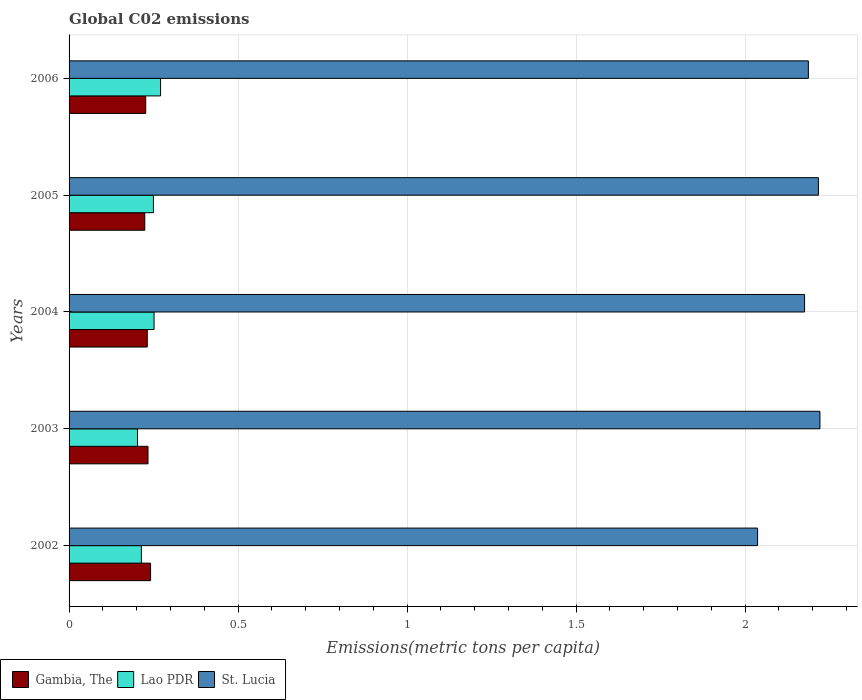How many different coloured bars are there?
Your answer should be compact. 3. Are the number of bars on each tick of the Y-axis equal?
Offer a terse response. Yes. How many bars are there on the 2nd tick from the top?
Keep it short and to the point. 3. What is the label of the 4th group of bars from the top?
Ensure brevity in your answer.  2003. What is the amount of CO2 emitted in in St. Lucia in 2002?
Provide a succinct answer. 2.04. Across all years, what is the maximum amount of CO2 emitted in in St. Lucia?
Provide a succinct answer. 2.22. Across all years, what is the minimum amount of CO2 emitted in in St. Lucia?
Offer a very short reply. 2.04. In which year was the amount of CO2 emitted in in Gambia, The minimum?
Make the answer very short. 2005. What is the total amount of CO2 emitted in in Gambia, The in the graph?
Provide a succinct answer. 1.16. What is the difference between the amount of CO2 emitted in in Gambia, The in 2005 and that in 2006?
Make the answer very short. -0. What is the difference between the amount of CO2 emitted in in Gambia, The in 2004 and the amount of CO2 emitted in in Lao PDR in 2003?
Provide a short and direct response. 0.03. What is the average amount of CO2 emitted in in St. Lucia per year?
Keep it short and to the point. 2.17. In the year 2006, what is the difference between the amount of CO2 emitted in in Gambia, The and amount of CO2 emitted in in Lao PDR?
Give a very brief answer. -0.04. In how many years, is the amount of CO2 emitted in in Gambia, The greater than 0.9 metric tons per capita?
Your answer should be very brief. 0. What is the ratio of the amount of CO2 emitted in in Gambia, The in 2005 to that in 2006?
Your answer should be compact. 0.99. What is the difference between the highest and the second highest amount of CO2 emitted in in Gambia, The?
Offer a very short reply. 0.01. What is the difference between the highest and the lowest amount of CO2 emitted in in Lao PDR?
Your response must be concise. 0.07. In how many years, is the amount of CO2 emitted in in St. Lucia greater than the average amount of CO2 emitted in in St. Lucia taken over all years?
Provide a short and direct response. 4. Is the sum of the amount of CO2 emitted in in Gambia, The in 2002 and 2005 greater than the maximum amount of CO2 emitted in in Lao PDR across all years?
Provide a succinct answer. Yes. What does the 1st bar from the top in 2003 represents?
Make the answer very short. St. Lucia. What does the 1st bar from the bottom in 2004 represents?
Ensure brevity in your answer.  Gambia, The. Are all the bars in the graph horizontal?
Ensure brevity in your answer.  Yes. How many legend labels are there?
Make the answer very short. 3. What is the title of the graph?
Give a very brief answer. Global C02 emissions. What is the label or title of the X-axis?
Offer a very short reply. Emissions(metric tons per capita). What is the Emissions(metric tons per capita) in Gambia, The in 2002?
Offer a terse response. 0.24. What is the Emissions(metric tons per capita) in Lao PDR in 2002?
Your answer should be compact. 0.21. What is the Emissions(metric tons per capita) in St. Lucia in 2002?
Provide a short and direct response. 2.04. What is the Emissions(metric tons per capita) in Gambia, The in 2003?
Offer a terse response. 0.23. What is the Emissions(metric tons per capita) in Lao PDR in 2003?
Your answer should be very brief. 0.2. What is the Emissions(metric tons per capita) in St. Lucia in 2003?
Your response must be concise. 2.22. What is the Emissions(metric tons per capita) in Gambia, The in 2004?
Provide a succinct answer. 0.23. What is the Emissions(metric tons per capita) of Lao PDR in 2004?
Ensure brevity in your answer.  0.25. What is the Emissions(metric tons per capita) of St. Lucia in 2004?
Your response must be concise. 2.18. What is the Emissions(metric tons per capita) of Gambia, The in 2005?
Keep it short and to the point. 0.22. What is the Emissions(metric tons per capita) of Lao PDR in 2005?
Your response must be concise. 0.25. What is the Emissions(metric tons per capita) of St. Lucia in 2005?
Keep it short and to the point. 2.22. What is the Emissions(metric tons per capita) of Gambia, The in 2006?
Give a very brief answer. 0.23. What is the Emissions(metric tons per capita) of Lao PDR in 2006?
Your response must be concise. 0.27. What is the Emissions(metric tons per capita) in St. Lucia in 2006?
Your response must be concise. 2.19. Across all years, what is the maximum Emissions(metric tons per capita) of Gambia, The?
Your response must be concise. 0.24. Across all years, what is the maximum Emissions(metric tons per capita) in Lao PDR?
Your answer should be very brief. 0.27. Across all years, what is the maximum Emissions(metric tons per capita) in St. Lucia?
Provide a short and direct response. 2.22. Across all years, what is the minimum Emissions(metric tons per capita) of Gambia, The?
Ensure brevity in your answer.  0.22. Across all years, what is the minimum Emissions(metric tons per capita) in Lao PDR?
Keep it short and to the point. 0.2. Across all years, what is the minimum Emissions(metric tons per capita) in St. Lucia?
Offer a very short reply. 2.04. What is the total Emissions(metric tons per capita) in Gambia, The in the graph?
Give a very brief answer. 1.16. What is the total Emissions(metric tons per capita) of Lao PDR in the graph?
Offer a very short reply. 1.19. What is the total Emissions(metric tons per capita) in St. Lucia in the graph?
Your answer should be very brief. 10.84. What is the difference between the Emissions(metric tons per capita) in Gambia, The in 2002 and that in 2003?
Give a very brief answer. 0.01. What is the difference between the Emissions(metric tons per capita) in Lao PDR in 2002 and that in 2003?
Offer a terse response. 0.01. What is the difference between the Emissions(metric tons per capita) of St. Lucia in 2002 and that in 2003?
Offer a terse response. -0.18. What is the difference between the Emissions(metric tons per capita) in Gambia, The in 2002 and that in 2004?
Provide a succinct answer. 0.01. What is the difference between the Emissions(metric tons per capita) of Lao PDR in 2002 and that in 2004?
Make the answer very short. -0.04. What is the difference between the Emissions(metric tons per capita) of St. Lucia in 2002 and that in 2004?
Ensure brevity in your answer.  -0.14. What is the difference between the Emissions(metric tons per capita) in Gambia, The in 2002 and that in 2005?
Your answer should be compact. 0.02. What is the difference between the Emissions(metric tons per capita) of Lao PDR in 2002 and that in 2005?
Your answer should be very brief. -0.04. What is the difference between the Emissions(metric tons per capita) of St. Lucia in 2002 and that in 2005?
Ensure brevity in your answer.  -0.18. What is the difference between the Emissions(metric tons per capita) in Gambia, The in 2002 and that in 2006?
Provide a succinct answer. 0.01. What is the difference between the Emissions(metric tons per capita) of Lao PDR in 2002 and that in 2006?
Your answer should be compact. -0.06. What is the difference between the Emissions(metric tons per capita) of St. Lucia in 2002 and that in 2006?
Ensure brevity in your answer.  -0.15. What is the difference between the Emissions(metric tons per capita) of Gambia, The in 2003 and that in 2004?
Provide a succinct answer. 0. What is the difference between the Emissions(metric tons per capita) in Lao PDR in 2003 and that in 2004?
Provide a short and direct response. -0.05. What is the difference between the Emissions(metric tons per capita) in St. Lucia in 2003 and that in 2004?
Provide a succinct answer. 0.05. What is the difference between the Emissions(metric tons per capita) in Gambia, The in 2003 and that in 2005?
Your answer should be very brief. 0.01. What is the difference between the Emissions(metric tons per capita) in Lao PDR in 2003 and that in 2005?
Ensure brevity in your answer.  -0.05. What is the difference between the Emissions(metric tons per capita) in St. Lucia in 2003 and that in 2005?
Provide a succinct answer. 0. What is the difference between the Emissions(metric tons per capita) in Gambia, The in 2003 and that in 2006?
Offer a very short reply. 0.01. What is the difference between the Emissions(metric tons per capita) of Lao PDR in 2003 and that in 2006?
Your response must be concise. -0.07. What is the difference between the Emissions(metric tons per capita) of St. Lucia in 2003 and that in 2006?
Offer a terse response. 0.03. What is the difference between the Emissions(metric tons per capita) of Gambia, The in 2004 and that in 2005?
Give a very brief answer. 0.01. What is the difference between the Emissions(metric tons per capita) of Lao PDR in 2004 and that in 2005?
Provide a succinct answer. 0. What is the difference between the Emissions(metric tons per capita) of St. Lucia in 2004 and that in 2005?
Offer a terse response. -0.04. What is the difference between the Emissions(metric tons per capita) of Gambia, The in 2004 and that in 2006?
Provide a short and direct response. 0. What is the difference between the Emissions(metric tons per capita) in Lao PDR in 2004 and that in 2006?
Ensure brevity in your answer.  -0.02. What is the difference between the Emissions(metric tons per capita) in St. Lucia in 2004 and that in 2006?
Provide a short and direct response. -0.01. What is the difference between the Emissions(metric tons per capita) of Gambia, The in 2005 and that in 2006?
Ensure brevity in your answer.  -0. What is the difference between the Emissions(metric tons per capita) of Lao PDR in 2005 and that in 2006?
Ensure brevity in your answer.  -0.02. What is the difference between the Emissions(metric tons per capita) in St. Lucia in 2005 and that in 2006?
Your answer should be compact. 0.03. What is the difference between the Emissions(metric tons per capita) in Gambia, The in 2002 and the Emissions(metric tons per capita) in Lao PDR in 2003?
Provide a short and direct response. 0.04. What is the difference between the Emissions(metric tons per capita) of Gambia, The in 2002 and the Emissions(metric tons per capita) of St. Lucia in 2003?
Ensure brevity in your answer.  -1.98. What is the difference between the Emissions(metric tons per capita) of Lao PDR in 2002 and the Emissions(metric tons per capita) of St. Lucia in 2003?
Provide a short and direct response. -2.01. What is the difference between the Emissions(metric tons per capita) in Gambia, The in 2002 and the Emissions(metric tons per capita) in Lao PDR in 2004?
Provide a succinct answer. -0.01. What is the difference between the Emissions(metric tons per capita) of Gambia, The in 2002 and the Emissions(metric tons per capita) of St. Lucia in 2004?
Your response must be concise. -1.93. What is the difference between the Emissions(metric tons per capita) of Lao PDR in 2002 and the Emissions(metric tons per capita) of St. Lucia in 2004?
Provide a short and direct response. -1.96. What is the difference between the Emissions(metric tons per capita) of Gambia, The in 2002 and the Emissions(metric tons per capita) of Lao PDR in 2005?
Your answer should be compact. -0.01. What is the difference between the Emissions(metric tons per capita) in Gambia, The in 2002 and the Emissions(metric tons per capita) in St. Lucia in 2005?
Provide a short and direct response. -1.98. What is the difference between the Emissions(metric tons per capita) of Lao PDR in 2002 and the Emissions(metric tons per capita) of St. Lucia in 2005?
Ensure brevity in your answer.  -2. What is the difference between the Emissions(metric tons per capita) in Gambia, The in 2002 and the Emissions(metric tons per capita) in Lao PDR in 2006?
Your answer should be very brief. -0.03. What is the difference between the Emissions(metric tons per capita) in Gambia, The in 2002 and the Emissions(metric tons per capita) in St. Lucia in 2006?
Give a very brief answer. -1.95. What is the difference between the Emissions(metric tons per capita) of Lao PDR in 2002 and the Emissions(metric tons per capita) of St. Lucia in 2006?
Keep it short and to the point. -1.97. What is the difference between the Emissions(metric tons per capita) in Gambia, The in 2003 and the Emissions(metric tons per capita) in Lao PDR in 2004?
Give a very brief answer. -0.02. What is the difference between the Emissions(metric tons per capita) of Gambia, The in 2003 and the Emissions(metric tons per capita) of St. Lucia in 2004?
Your response must be concise. -1.94. What is the difference between the Emissions(metric tons per capita) of Lao PDR in 2003 and the Emissions(metric tons per capita) of St. Lucia in 2004?
Your answer should be very brief. -1.97. What is the difference between the Emissions(metric tons per capita) in Gambia, The in 2003 and the Emissions(metric tons per capita) in Lao PDR in 2005?
Keep it short and to the point. -0.02. What is the difference between the Emissions(metric tons per capita) in Gambia, The in 2003 and the Emissions(metric tons per capita) in St. Lucia in 2005?
Keep it short and to the point. -1.98. What is the difference between the Emissions(metric tons per capita) of Lao PDR in 2003 and the Emissions(metric tons per capita) of St. Lucia in 2005?
Your response must be concise. -2.01. What is the difference between the Emissions(metric tons per capita) in Gambia, The in 2003 and the Emissions(metric tons per capita) in Lao PDR in 2006?
Provide a succinct answer. -0.04. What is the difference between the Emissions(metric tons per capita) in Gambia, The in 2003 and the Emissions(metric tons per capita) in St. Lucia in 2006?
Keep it short and to the point. -1.95. What is the difference between the Emissions(metric tons per capita) in Lao PDR in 2003 and the Emissions(metric tons per capita) in St. Lucia in 2006?
Your response must be concise. -1.98. What is the difference between the Emissions(metric tons per capita) of Gambia, The in 2004 and the Emissions(metric tons per capita) of Lao PDR in 2005?
Make the answer very short. -0.02. What is the difference between the Emissions(metric tons per capita) of Gambia, The in 2004 and the Emissions(metric tons per capita) of St. Lucia in 2005?
Your answer should be compact. -1.99. What is the difference between the Emissions(metric tons per capita) of Lao PDR in 2004 and the Emissions(metric tons per capita) of St. Lucia in 2005?
Offer a very short reply. -1.97. What is the difference between the Emissions(metric tons per capita) in Gambia, The in 2004 and the Emissions(metric tons per capita) in Lao PDR in 2006?
Offer a very short reply. -0.04. What is the difference between the Emissions(metric tons per capita) of Gambia, The in 2004 and the Emissions(metric tons per capita) of St. Lucia in 2006?
Provide a short and direct response. -1.96. What is the difference between the Emissions(metric tons per capita) of Lao PDR in 2004 and the Emissions(metric tons per capita) of St. Lucia in 2006?
Your answer should be compact. -1.94. What is the difference between the Emissions(metric tons per capita) of Gambia, The in 2005 and the Emissions(metric tons per capita) of Lao PDR in 2006?
Your answer should be compact. -0.05. What is the difference between the Emissions(metric tons per capita) of Gambia, The in 2005 and the Emissions(metric tons per capita) of St. Lucia in 2006?
Offer a terse response. -1.96. What is the difference between the Emissions(metric tons per capita) of Lao PDR in 2005 and the Emissions(metric tons per capita) of St. Lucia in 2006?
Give a very brief answer. -1.94. What is the average Emissions(metric tons per capita) of Gambia, The per year?
Your answer should be very brief. 0.23. What is the average Emissions(metric tons per capita) of Lao PDR per year?
Provide a short and direct response. 0.24. What is the average Emissions(metric tons per capita) of St. Lucia per year?
Offer a very short reply. 2.17. In the year 2002, what is the difference between the Emissions(metric tons per capita) of Gambia, The and Emissions(metric tons per capita) of Lao PDR?
Give a very brief answer. 0.03. In the year 2002, what is the difference between the Emissions(metric tons per capita) of Gambia, The and Emissions(metric tons per capita) of St. Lucia?
Your answer should be compact. -1.8. In the year 2002, what is the difference between the Emissions(metric tons per capita) in Lao PDR and Emissions(metric tons per capita) in St. Lucia?
Provide a short and direct response. -1.82. In the year 2003, what is the difference between the Emissions(metric tons per capita) in Gambia, The and Emissions(metric tons per capita) in Lao PDR?
Provide a short and direct response. 0.03. In the year 2003, what is the difference between the Emissions(metric tons per capita) of Gambia, The and Emissions(metric tons per capita) of St. Lucia?
Offer a terse response. -1.99. In the year 2003, what is the difference between the Emissions(metric tons per capita) of Lao PDR and Emissions(metric tons per capita) of St. Lucia?
Ensure brevity in your answer.  -2.02. In the year 2004, what is the difference between the Emissions(metric tons per capita) of Gambia, The and Emissions(metric tons per capita) of Lao PDR?
Your answer should be very brief. -0.02. In the year 2004, what is the difference between the Emissions(metric tons per capita) of Gambia, The and Emissions(metric tons per capita) of St. Lucia?
Make the answer very short. -1.94. In the year 2004, what is the difference between the Emissions(metric tons per capita) of Lao PDR and Emissions(metric tons per capita) of St. Lucia?
Your answer should be very brief. -1.92. In the year 2005, what is the difference between the Emissions(metric tons per capita) of Gambia, The and Emissions(metric tons per capita) of Lao PDR?
Make the answer very short. -0.03. In the year 2005, what is the difference between the Emissions(metric tons per capita) in Gambia, The and Emissions(metric tons per capita) in St. Lucia?
Provide a succinct answer. -1.99. In the year 2005, what is the difference between the Emissions(metric tons per capita) of Lao PDR and Emissions(metric tons per capita) of St. Lucia?
Your answer should be very brief. -1.97. In the year 2006, what is the difference between the Emissions(metric tons per capita) of Gambia, The and Emissions(metric tons per capita) of Lao PDR?
Provide a succinct answer. -0.04. In the year 2006, what is the difference between the Emissions(metric tons per capita) in Gambia, The and Emissions(metric tons per capita) in St. Lucia?
Your response must be concise. -1.96. In the year 2006, what is the difference between the Emissions(metric tons per capita) in Lao PDR and Emissions(metric tons per capita) in St. Lucia?
Your answer should be very brief. -1.92. What is the ratio of the Emissions(metric tons per capita) of Gambia, The in 2002 to that in 2003?
Provide a short and direct response. 1.03. What is the ratio of the Emissions(metric tons per capita) in Lao PDR in 2002 to that in 2003?
Make the answer very short. 1.06. What is the ratio of the Emissions(metric tons per capita) in St. Lucia in 2002 to that in 2003?
Your response must be concise. 0.92. What is the ratio of the Emissions(metric tons per capita) in Gambia, The in 2002 to that in 2004?
Provide a succinct answer. 1.04. What is the ratio of the Emissions(metric tons per capita) of Lao PDR in 2002 to that in 2004?
Provide a short and direct response. 0.85. What is the ratio of the Emissions(metric tons per capita) of St. Lucia in 2002 to that in 2004?
Provide a short and direct response. 0.94. What is the ratio of the Emissions(metric tons per capita) in Gambia, The in 2002 to that in 2005?
Provide a short and direct response. 1.08. What is the ratio of the Emissions(metric tons per capita) of Lao PDR in 2002 to that in 2005?
Provide a short and direct response. 0.86. What is the ratio of the Emissions(metric tons per capita) of St. Lucia in 2002 to that in 2005?
Offer a very short reply. 0.92. What is the ratio of the Emissions(metric tons per capita) in Gambia, The in 2002 to that in 2006?
Offer a very short reply. 1.06. What is the ratio of the Emissions(metric tons per capita) of Lao PDR in 2002 to that in 2006?
Your response must be concise. 0.79. What is the ratio of the Emissions(metric tons per capita) in St. Lucia in 2002 to that in 2006?
Offer a very short reply. 0.93. What is the ratio of the Emissions(metric tons per capita) of Gambia, The in 2003 to that in 2004?
Offer a terse response. 1.01. What is the ratio of the Emissions(metric tons per capita) in Lao PDR in 2003 to that in 2004?
Ensure brevity in your answer.  0.81. What is the ratio of the Emissions(metric tons per capita) in St. Lucia in 2003 to that in 2004?
Provide a succinct answer. 1.02. What is the ratio of the Emissions(metric tons per capita) of Gambia, The in 2003 to that in 2005?
Give a very brief answer. 1.04. What is the ratio of the Emissions(metric tons per capita) in Lao PDR in 2003 to that in 2005?
Make the answer very short. 0.81. What is the ratio of the Emissions(metric tons per capita) in Gambia, The in 2003 to that in 2006?
Offer a terse response. 1.03. What is the ratio of the Emissions(metric tons per capita) in Lao PDR in 2003 to that in 2006?
Ensure brevity in your answer.  0.75. What is the ratio of the Emissions(metric tons per capita) in St. Lucia in 2003 to that in 2006?
Your answer should be very brief. 1.02. What is the ratio of the Emissions(metric tons per capita) of Gambia, The in 2004 to that in 2005?
Your response must be concise. 1.03. What is the ratio of the Emissions(metric tons per capita) in Lao PDR in 2004 to that in 2005?
Offer a terse response. 1.01. What is the ratio of the Emissions(metric tons per capita) in St. Lucia in 2004 to that in 2005?
Your response must be concise. 0.98. What is the ratio of the Emissions(metric tons per capita) of Gambia, The in 2004 to that in 2006?
Your response must be concise. 1.02. What is the ratio of the Emissions(metric tons per capita) of Lao PDR in 2004 to that in 2006?
Your response must be concise. 0.93. What is the ratio of the Emissions(metric tons per capita) of St. Lucia in 2004 to that in 2006?
Ensure brevity in your answer.  0.99. What is the ratio of the Emissions(metric tons per capita) in Gambia, The in 2005 to that in 2006?
Your response must be concise. 0.99. What is the ratio of the Emissions(metric tons per capita) of Lao PDR in 2005 to that in 2006?
Offer a terse response. 0.92. What is the ratio of the Emissions(metric tons per capita) in St. Lucia in 2005 to that in 2006?
Ensure brevity in your answer.  1.01. What is the difference between the highest and the second highest Emissions(metric tons per capita) in Gambia, The?
Your response must be concise. 0.01. What is the difference between the highest and the second highest Emissions(metric tons per capita) of Lao PDR?
Your answer should be compact. 0.02. What is the difference between the highest and the second highest Emissions(metric tons per capita) in St. Lucia?
Your answer should be compact. 0. What is the difference between the highest and the lowest Emissions(metric tons per capita) in Gambia, The?
Provide a short and direct response. 0.02. What is the difference between the highest and the lowest Emissions(metric tons per capita) in Lao PDR?
Provide a short and direct response. 0.07. What is the difference between the highest and the lowest Emissions(metric tons per capita) in St. Lucia?
Offer a very short reply. 0.18. 